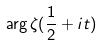Convert formula to latex. <formula><loc_0><loc_0><loc_500><loc_500>\arg \zeta ( \frac { 1 } { 2 } + i t )</formula> 